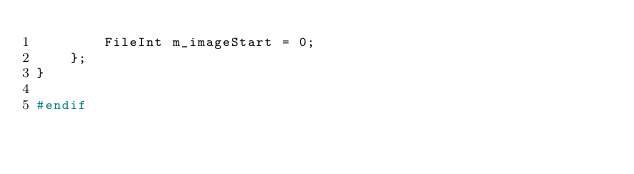<code> <loc_0><loc_0><loc_500><loc_500><_C_>		FileInt m_imageStart = 0;
	};
}

#endif
</code> 